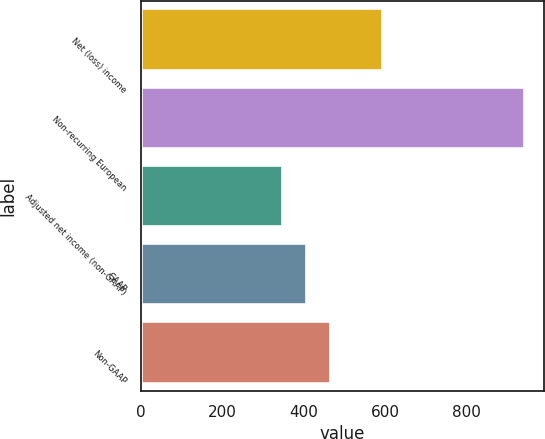Convert chart. <chart><loc_0><loc_0><loc_500><loc_500><bar_chart><fcel>Net (loss) income<fcel>Non-recurring European<fcel>Adjusted net income (non-GAAP)<fcel>GAAP<fcel>Non-GAAP<nl><fcel>594.6<fcel>942.6<fcel>348<fcel>407.46<fcel>466.92<nl></chart> 